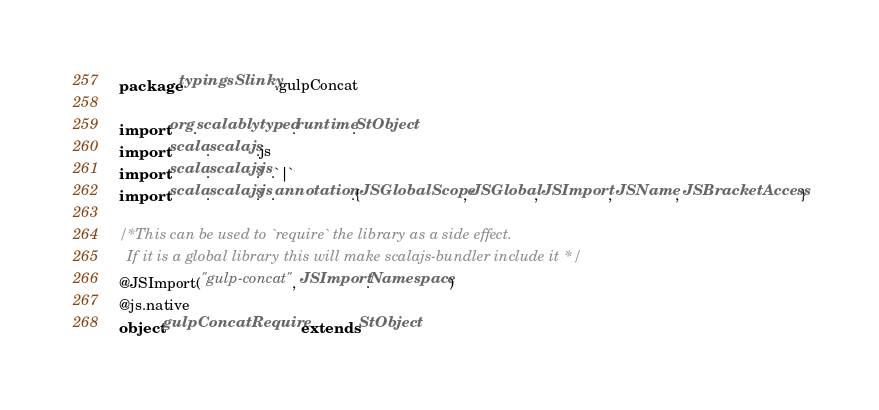Convert code to text. <code><loc_0><loc_0><loc_500><loc_500><_Scala_>package typingsSlinky.gulpConcat

import org.scalablytyped.runtime.StObject
import scala.scalajs.js
import scala.scalajs.js.`|`
import scala.scalajs.js.annotation.{JSGlobalScope, JSGlobal, JSImport, JSName, JSBracketAccess}

/* This can be used to `require` the library as a side effect.
  If it is a global library this will make scalajs-bundler include it */
@JSImport("gulp-concat", JSImport.Namespace)
@js.native
object gulpConcatRequire extends StObject
</code> 